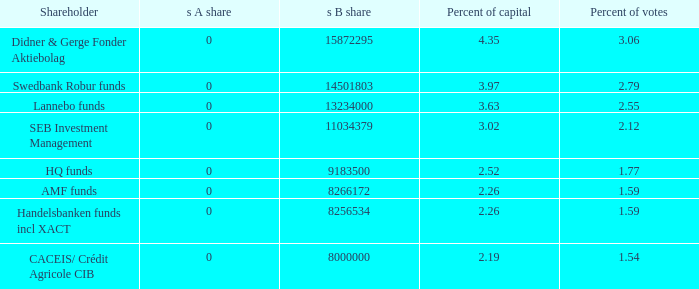What is the s b allotment for the shareholder possessing 13234000.0. 